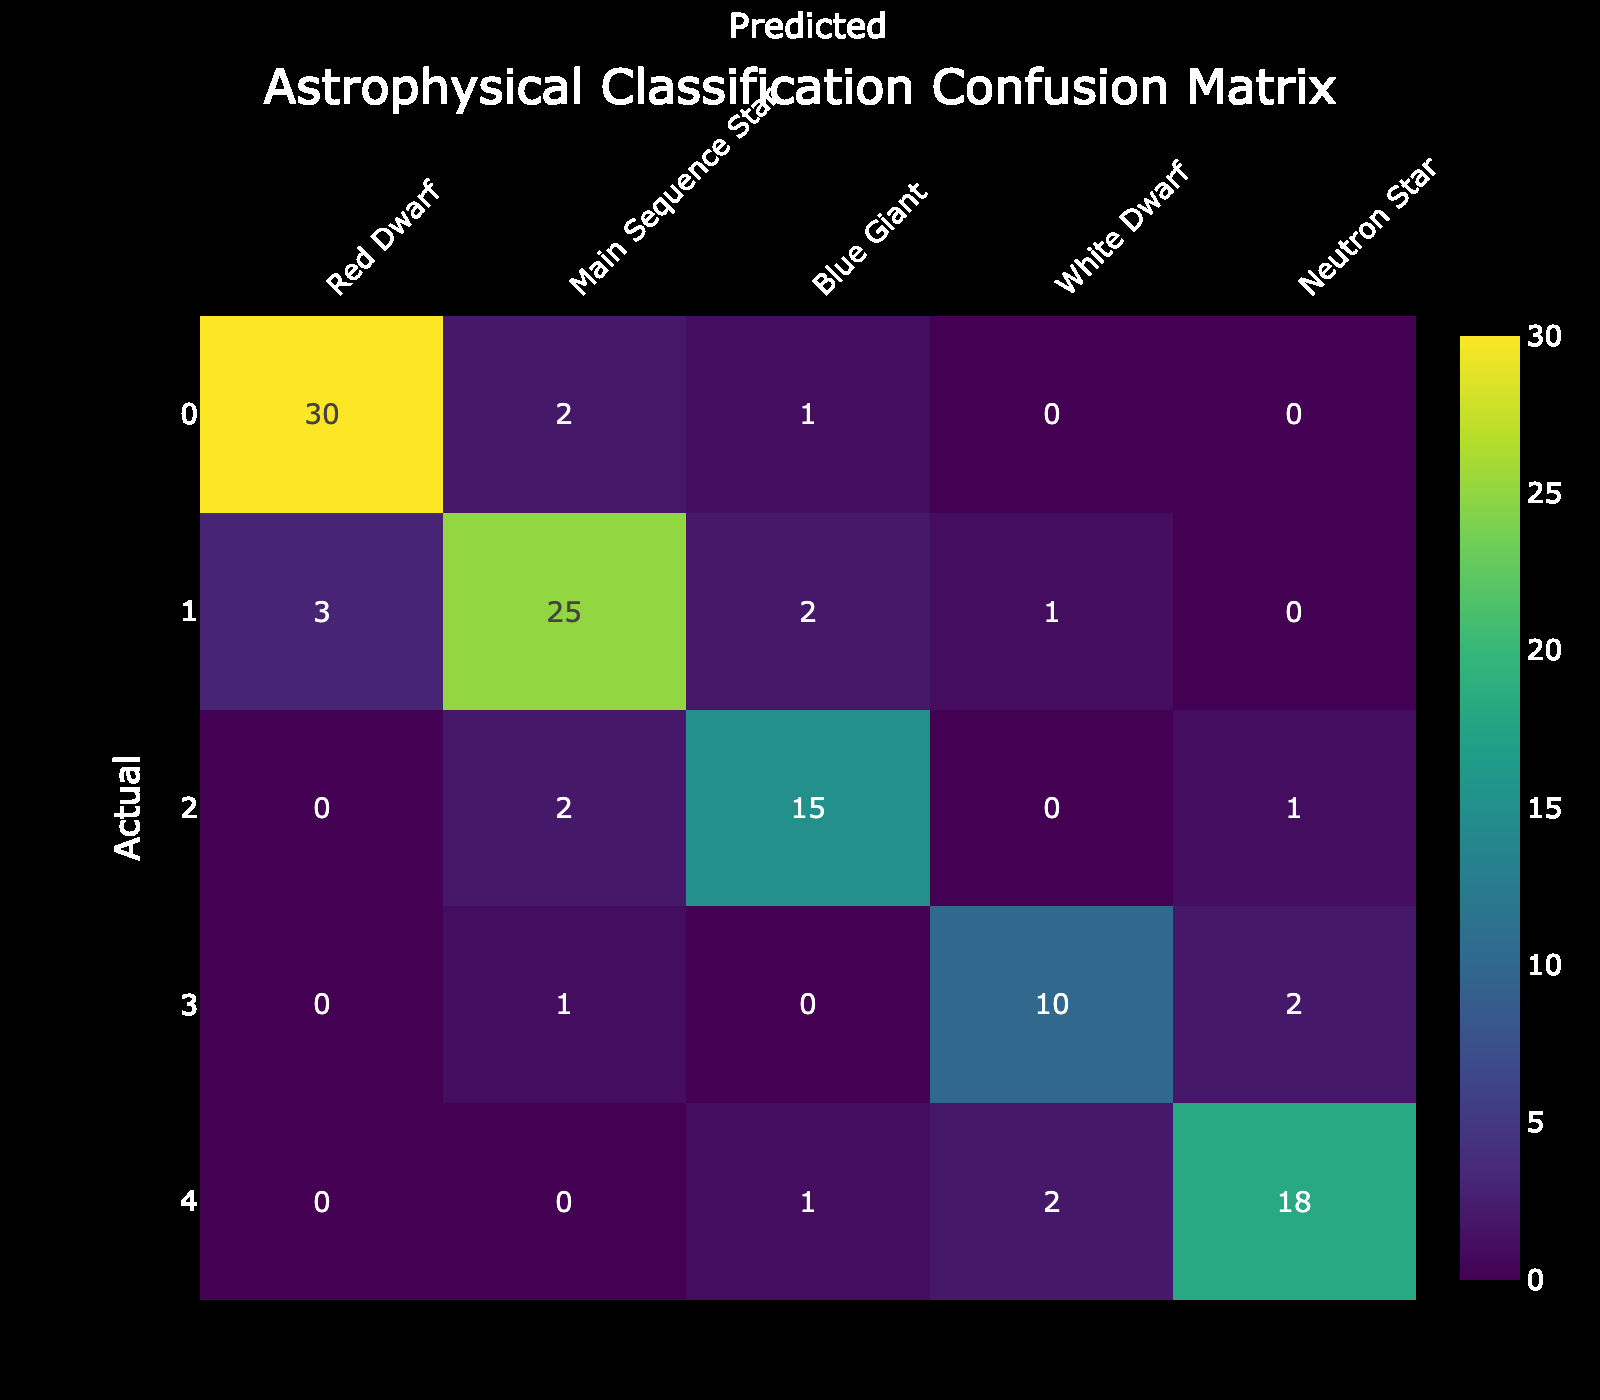What is the number of misclassified Red Dwarfs? The misclassified Red Dwarfs are represented by the values in the Red Dwarf row, except for the cell where the actual and predicted values match. The values are 2 (predicted as Main Sequence Star) and 1 (predicted as Blue Giant). Adding these gives us 2 + 1 = 3 misclassified Red Dwarfs.
Answer: 3 How many Blue Giants were correctly classified? The correctly classified Blue Giants are found in the Blue Giant row under the Blue Giant column. The value is 15, indicating that this many Blue Giants were classified correctly.
Answer: 15 What is the total number of Neutron Stars predicted as White Dwarfs? To find this, we look at the Neutron Star row and find the value under the White Dwarf column. The value is 2, indicating that 2 Neutron Stars were misclassified as White Dwarfs.
Answer: 2 What percentage of the total Main Sequence Stars were misclassified? To find the percentage, we first identify how many Main Sequence Stars were misclassified. They were predicted as Red Dwarfs (3), Blue Giants (2), and White Dwarfs (1). Thus, 3 + 2 + 1 = 6 were misclassified. The total number of actual Main Sequence Stars is 31 (correctly classified 25 plus misclassified 6). The percentage of misclassified is (6/31) * 100 = ~19.35%.
Answer: ~19.35% Are there any Neutron Stars that were classified as Main Sequence Stars? Looking at the Neutron Star row, the value in the Main Sequence prediction column is 0. This indicates that there were no Neutron Stars misclassified as Main Sequence Stars.
Answer: No Which type of star has the highest number of correct classifications? The correctly classified stars are found along the diagonal of the confusion matrix. By examining these values: Red Dwarf (30), Main Sequence Star (25), Blue Giant (15), White Dwarf (10), and Neutron Star (18). The highest value is 30 for Red Dwarfs, indicating they have the highest number of correct classifications.
Answer: Red Dwarf What is the total count of misclassifications across all types of stars? To find total misclassifications, we need to sum all the values that are not on the diagonal. This includes: 2 (Red Dwarf predicted as Main Sequence) + 1 (Red Dwarf predicted as Blue Giant) + 3 (Main Sequence misclassified into Red Dwarf) + 2 (Main Sequence misclassified into Blue Giant) + 1 (Main Sequence into White Dwarf) + 2 (Blue Giant into Neutron Star) + 1 (White Dwarf into Main Sequence) + 0 (White Dwarf into Blue Giant) + 2 (White Dwarf into Neutron Star) + 1 (Neutron Star into Blue Giant) + 2 (Neutron Star into White Dwarf). Summing these gives a total of 18 misclassifications.
Answer: 18 How many stars were classified as Blue Giants altogether? The total classified as Blue Giants can be found by summing predictions in the Blue Giant column. The values are 2 (actual Red Dwarfs) + 15 (actual Blue Giants) + 2 (actual Main Sequence Stars) + 0 (actual White Dwarfs) + 1 (actual Neutron Stars) resulting in 20 stars being classified as Blue Giants.
Answer: 20 